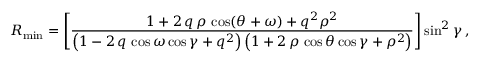<formula> <loc_0><loc_0><loc_500><loc_500>R _ { \min } = \left [ \frac { 1 + 2 \, q \, \rho \, \cos ( \theta + \omega ) + q ^ { 2 } \rho ^ { 2 } } { \left ( 1 - 2 \, q \, \cos \omega \cos \gamma + q ^ { 2 } \right ) \left ( 1 + 2 \, \rho \, \cos \theta \cos \gamma + \rho ^ { 2 } \right ) } \right ] \sin ^ { 2 } \gamma \, ,</formula> 